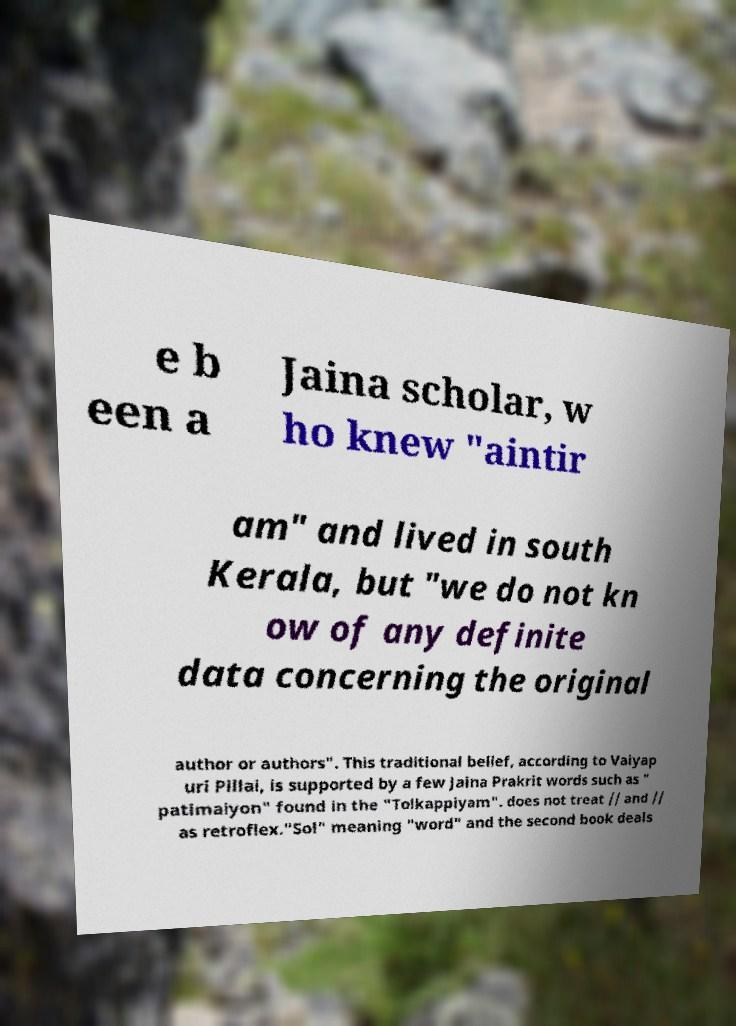Please identify and transcribe the text found in this image. e b een a Jaina scholar, w ho knew "aintir am" and lived in south Kerala, but "we do not kn ow of any definite data concerning the original author or authors". This traditional belief, according to Vaiyap uri Pillai, is supported by a few Jaina Prakrit words such as " patimaiyon" found in the "Tolkappiyam". does not treat // and // as retroflex."Sol" meaning "word" and the second book deals 